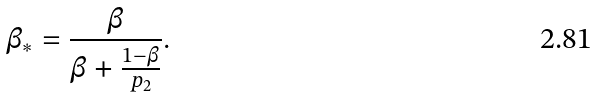Convert formula to latex. <formula><loc_0><loc_0><loc_500><loc_500>\beta _ { \ast } = \frac { \beta } { \beta + \frac { 1 - \beta } { p _ { 2 } } } .</formula> 